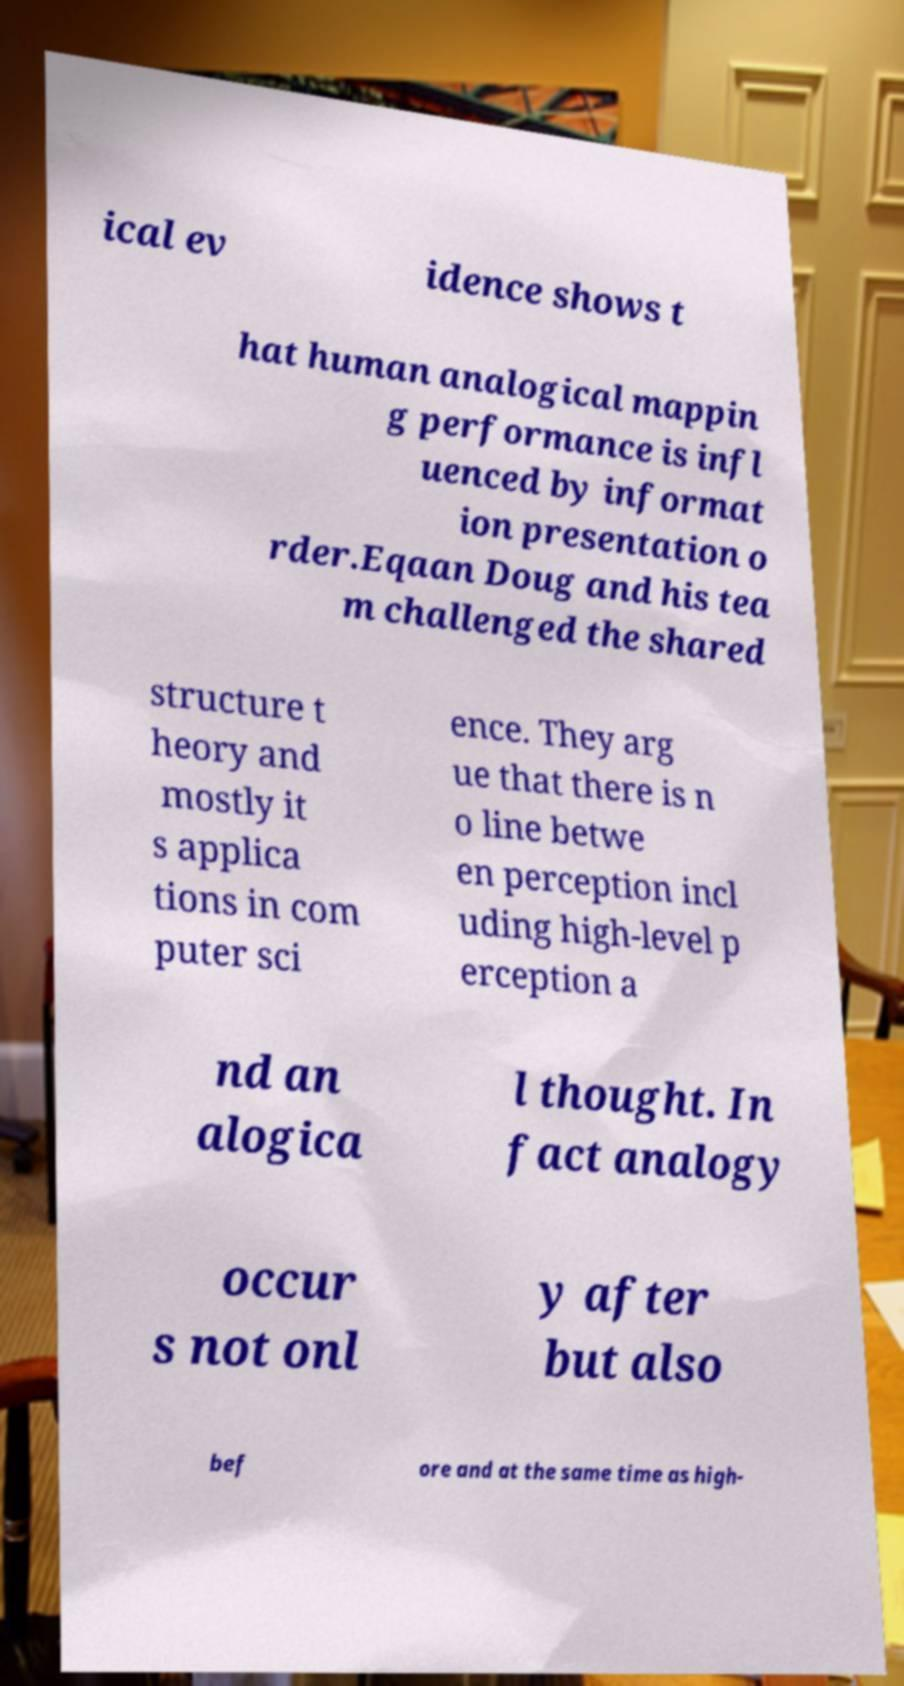Could you assist in decoding the text presented in this image and type it out clearly? ical ev idence shows t hat human analogical mappin g performance is infl uenced by informat ion presentation o rder.Eqaan Doug and his tea m challenged the shared structure t heory and mostly it s applica tions in com puter sci ence. They arg ue that there is n o line betwe en perception incl uding high-level p erception a nd an alogica l thought. In fact analogy occur s not onl y after but also bef ore and at the same time as high- 